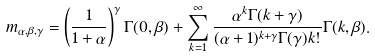<formula> <loc_0><loc_0><loc_500><loc_500>m _ { \alpha , \beta , \gamma } = \left ( \frac { 1 } { 1 + \alpha } \right ) ^ { \gamma } \Gamma ( 0 , \beta ) + \sum _ { k = 1 } ^ { \infty } \frac { \alpha ^ { k } \Gamma ( k + \gamma ) } { ( \alpha + 1 ) ^ { k + \gamma } \Gamma ( \gamma ) k ! } \Gamma ( k , \beta ) .</formula> 